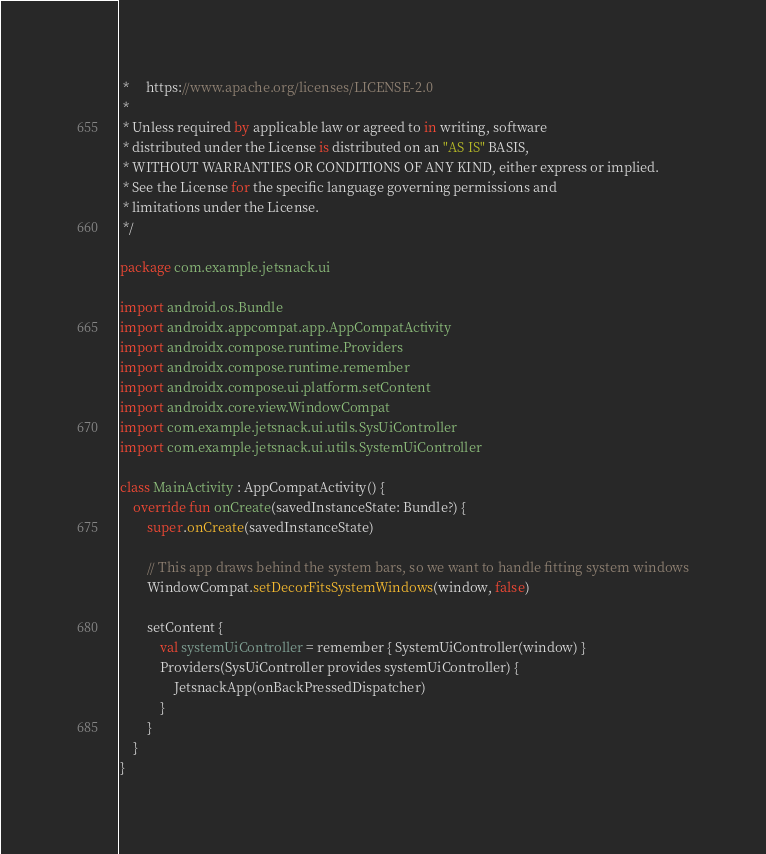Convert code to text. <code><loc_0><loc_0><loc_500><loc_500><_Kotlin_> *     https://www.apache.org/licenses/LICENSE-2.0
 *
 * Unless required by applicable law or agreed to in writing, software
 * distributed under the License is distributed on an "AS IS" BASIS,
 * WITHOUT WARRANTIES OR CONDITIONS OF ANY KIND, either express or implied.
 * See the License for the specific language governing permissions and
 * limitations under the License.
 */

package com.example.jetsnack.ui

import android.os.Bundle
import androidx.appcompat.app.AppCompatActivity
import androidx.compose.runtime.Providers
import androidx.compose.runtime.remember
import androidx.compose.ui.platform.setContent
import androidx.core.view.WindowCompat
import com.example.jetsnack.ui.utils.SysUiController
import com.example.jetsnack.ui.utils.SystemUiController

class MainActivity : AppCompatActivity() {
    override fun onCreate(savedInstanceState: Bundle?) {
        super.onCreate(savedInstanceState)

        // This app draws behind the system bars, so we want to handle fitting system windows
        WindowCompat.setDecorFitsSystemWindows(window, false)

        setContent {
            val systemUiController = remember { SystemUiController(window) }
            Providers(SysUiController provides systemUiController) {
                JetsnackApp(onBackPressedDispatcher)
            }
        }
    }
}
</code> 